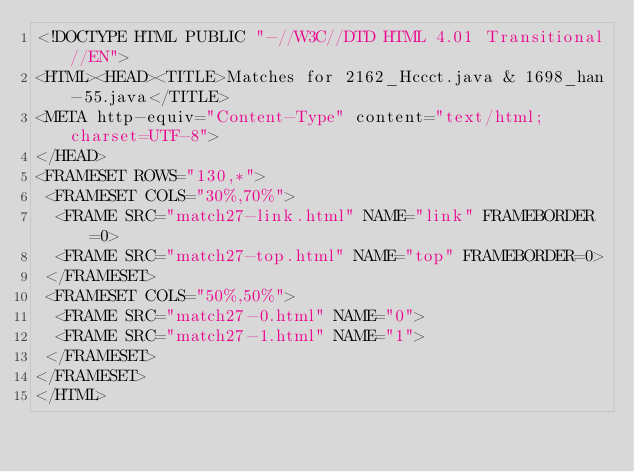<code> <loc_0><loc_0><loc_500><loc_500><_HTML_><!DOCTYPE HTML PUBLIC "-//W3C//DTD HTML 4.01 Transitional//EN">
<HTML><HEAD><TITLE>Matches for 2162_Hccct.java & 1698_han-55.java</TITLE>
<META http-equiv="Content-Type" content="text/html; charset=UTF-8">
</HEAD>
<FRAMESET ROWS="130,*">
 <FRAMESET COLS="30%,70%">
  <FRAME SRC="match27-link.html" NAME="link" FRAMEBORDER=0>
  <FRAME SRC="match27-top.html" NAME="top" FRAMEBORDER=0>
 </FRAMESET>
 <FRAMESET COLS="50%,50%">
  <FRAME SRC="match27-0.html" NAME="0">
  <FRAME SRC="match27-1.html" NAME="1">
 </FRAMESET>
</FRAMESET>
</HTML>
</code> 